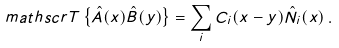<formula> <loc_0><loc_0><loc_500><loc_500>\ m a t h s c r { T } \left \{ \hat { A } ( x ) \hat { B } ( y ) \right \} = \sum _ { i } C _ { i } ( x - y ) \hat { N } _ { i } ( x ) \, .</formula> 